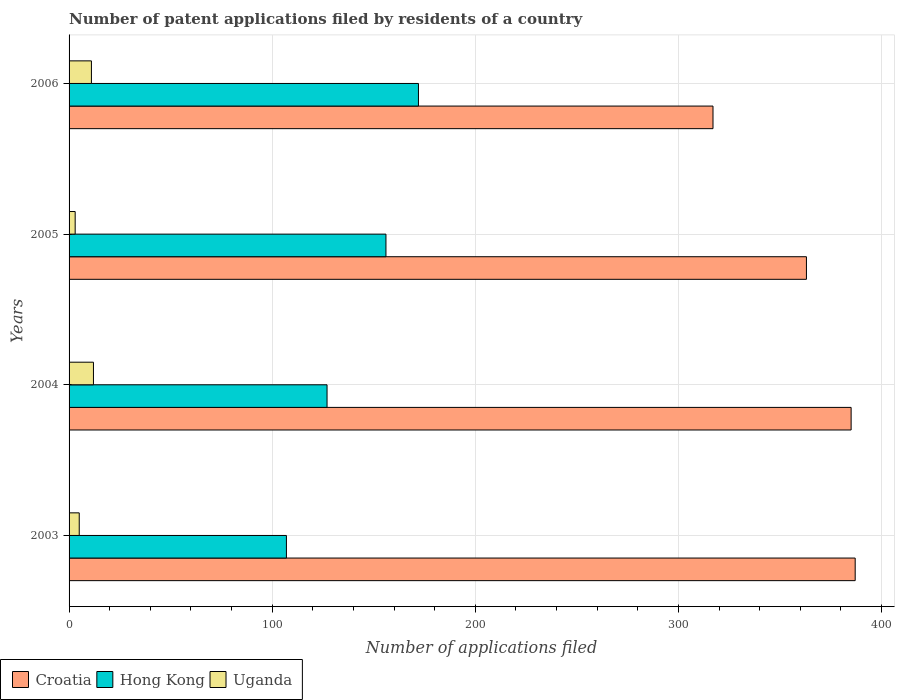How many groups of bars are there?
Provide a succinct answer. 4. How many bars are there on the 3rd tick from the bottom?
Your answer should be very brief. 3. What is the label of the 3rd group of bars from the top?
Provide a succinct answer. 2004. In how many cases, is the number of bars for a given year not equal to the number of legend labels?
Provide a short and direct response. 0. What is the number of applications filed in Hong Kong in 2003?
Your answer should be very brief. 107. Across all years, what is the minimum number of applications filed in Hong Kong?
Your answer should be very brief. 107. In which year was the number of applications filed in Uganda maximum?
Your answer should be very brief. 2004. What is the total number of applications filed in Hong Kong in the graph?
Your answer should be very brief. 562. What is the difference between the number of applications filed in Hong Kong in 2004 and the number of applications filed in Uganda in 2003?
Keep it short and to the point. 122. What is the average number of applications filed in Hong Kong per year?
Offer a very short reply. 140.5. In the year 2006, what is the difference between the number of applications filed in Uganda and number of applications filed in Hong Kong?
Ensure brevity in your answer.  -161. In how many years, is the number of applications filed in Hong Kong greater than 140 ?
Your answer should be compact. 2. What is the ratio of the number of applications filed in Hong Kong in 2005 to that in 2006?
Give a very brief answer. 0.91. Is the number of applications filed in Croatia in 2003 less than that in 2006?
Give a very brief answer. No. What is the difference between the highest and the second highest number of applications filed in Uganda?
Your answer should be very brief. 1. What does the 2nd bar from the top in 2006 represents?
Keep it short and to the point. Hong Kong. What does the 1st bar from the bottom in 2004 represents?
Give a very brief answer. Croatia. Are all the bars in the graph horizontal?
Your answer should be compact. Yes. How many years are there in the graph?
Offer a terse response. 4. What is the difference between two consecutive major ticks on the X-axis?
Give a very brief answer. 100. Are the values on the major ticks of X-axis written in scientific E-notation?
Offer a terse response. No. Where does the legend appear in the graph?
Your answer should be very brief. Bottom left. What is the title of the graph?
Keep it short and to the point. Number of patent applications filed by residents of a country. What is the label or title of the X-axis?
Your response must be concise. Number of applications filed. What is the label or title of the Y-axis?
Offer a terse response. Years. What is the Number of applications filed of Croatia in 2003?
Your answer should be compact. 387. What is the Number of applications filed in Hong Kong in 2003?
Give a very brief answer. 107. What is the Number of applications filed in Uganda in 2003?
Offer a very short reply. 5. What is the Number of applications filed in Croatia in 2004?
Offer a very short reply. 385. What is the Number of applications filed in Hong Kong in 2004?
Make the answer very short. 127. What is the Number of applications filed of Croatia in 2005?
Make the answer very short. 363. What is the Number of applications filed of Hong Kong in 2005?
Keep it short and to the point. 156. What is the Number of applications filed of Uganda in 2005?
Provide a short and direct response. 3. What is the Number of applications filed of Croatia in 2006?
Your response must be concise. 317. What is the Number of applications filed in Hong Kong in 2006?
Give a very brief answer. 172. Across all years, what is the maximum Number of applications filed of Croatia?
Your answer should be very brief. 387. Across all years, what is the maximum Number of applications filed of Hong Kong?
Ensure brevity in your answer.  172. Across all years, what is the minimum Number of applications filed of Croatia?
Provide a short and direct response. 317. Across all years, what is the minimum Number of applications filed of Hong Kong?
Make the answer very short. 107. What is the total Number of applications filed in Croatia in the graph?
Offer a very short reply. 1452. What is the total Number of applications filed in Hong Kong in the graph?
Give a very brief answer. 562. What is the total Number of applications filed in Uganda in the graph?
Your response must be concise. 31. What is the difference between the Number of applications filed in Croatia in 2003 and that in 2004?
Keep it short and to the point. 2. What is the difference between the Number of applications filed in Uganda in 2003 and that in 2004?
Offer a terse response. -7. What is the difference between the Number of applications filed in Hong Kong in 2003 and that in 2005?
Your answer should be compact. -49. What is the difference between the Number of applications filed in Croatia in 2003 and that in 2006?
Your answer should be very brief. 70. What is the difference between the Number of applications filed in Hong Kong in 2003 and that in 2006?
Offer a terse response. -65. What is the difference between the Number of applications filed of Uganda in 2003 and that in 2006?
Your answer should be compact. -6. What is the difference between the Number of applications filed in Croatia in 2004 and that in 2005?
Give a very brief answer. 22. What is the difference between the Number of applications filed of Uganda in 2004 and that in 2005?
Provide a short and direct response. 9. What is the difference between the Number of applications filed of Croatia in 2004 and that in 2006?
Ensure brevity in your answer.  68. What is the difference between the Number of applications filed in Hong Kong in 2004 and that in 2006?
Make the answer very short. -45. What is the difference between the Number of applications filed of Uganda in 2004 and that in 2006?
Give a very brief answer. 1. What is the difference between the Number of applications filed of Croatia in 2005 and that in 2006?
Your answer should be very brief. 46. What is the difference between the Number of applications filed in Croatia in 2003 and the Number of applications filed in Hong Kong in 2004?
Offer a terse response. 260. What is the difference between the Number of applications filed in Croatia in 2003 and the Number of applications filed in Uganda in 2004?
Make the answer very short. 375. What is the difference between the Number of applications filed of Hong Kong in 2003 and the Number of applications filed of Uganda in 2004?
Ensure brevity in your answer.  95. What is the difference between the Number of applications filed of Croatia in 2003 and the Number of applications filed of Hong Kong in 2005?
Make the answer very short. 231. What is the difference between the Number of applications filed of Croatia in 2003 and the Number of applications filed of Uganda in 2005?
Your response must be concise. 384. What is the difference between the Number of applications filed of Hong Kong in 2003 and the Number of applications filed of Uganda in 2005?
Offer a terse response. 104. What is the difference between the Number of applications filed of Croatia in 2003 and the Number of applications filed of Hong Kong in 2006?
Make the answer very short. 215. What is the difference between the Number of applications filed in Croatia in 2003 and the Number of applications filed in Uganda in 2006?
Your answer should be very brief. 376. What is the difference between the Number of applications filed in Hong Kong in 2003 and the Number of applications filed in Uganda in 2006?
Your answer should be very brief. 96. What is the difference between the Number of applications filed of Croatia in 2004 and the Number of applications filed of Hong Kong in 2005?
Ensure brevity in your answer.  229. What is the difference between the Number of applications filed of Croatia in 2004 and the Number of applications filed of Uganda in 2005?
Your answer should be very brief. 382. What is the difference between the Number of applications filed in Hong Kong in 2004 and the Number of applications filed in Uganda in 2005?
Provide a succinct answer. 124. What is the difference between the Number of applications filed of Croatia in 2004 and the Number of applications filed of Hong Kong in 2006?
Keep it short and to the point. 213. What is the difference between the Number of applications filed in Croatia in 2004 and the Number of applications filed in Uganda in 2006?
Make the answer very short. 374. What is the difference between the Number of applications filed in Hong Kong in 2004 and the Number of applications filed in Uganda in 2006?
Provide a succinct answer. 116. What is the difference between the Number of applications filed of Croatia in 2005 and the Number of applications filed of Hong Kong in 2006?
Keep it short and to the point. 191. What is the difference between the Number of applications filed in Croatia in 2005 and the Number of applications filed in Uganda in 2006?
Offer a very short reply. 352. What is the difference between the Number of applications filed in Hong Kong in 2005 and the Number of applications filed in Uganda in 2006?
Your response must be concise. 145. What is the average Number of applications filed in Croatia per year?
Your answer should be compact. 363. What is the average Number of applications filed in Hong Kong per year?
Provide a succinct answer. 140.5. What is the average Number of applications filed in Uganda per year?
Provide a short and direct response. 7.75. In the year 2003, what is the difference between the Number of applications filed in Croatia and Number of applications filed in Hong Kong?
Provide a succinct answer. 280. In the year 2003, what is the difference between the Number of applications filed of Croatia and Number of applications filed of Uganda?
Provide a short and direct response. 382. In the year 2003, what is the difference between the Number of applications filed of Hong Kong and Number of applications filed of Uganda?
Provide a succinct answer. 102. In the year 2004, what is the difference between the Number of applications filed in Croatia and Number of applications filed in Hong Kong?
Make the answer very short. 258. In the year 2004, what is the difference between the Number of applications filed of Croatia and Number of applications filed of Uganda?
Your answer should be compact. 373. In the year 2004, what is the difference between the Number of applications filed in Hong Kong and Number of applications filed in Uganda?
Make the answer very short. 115. In the year 2005, what is the difference between the Number of applications filed in Croatia and Number of applications filed in Hong Kong?
Offer a terse response. 207. In the year 2005, what is the difference between the Number of applications filed of Croatia and Number of applications filed of Uganda?
Offer a terse response. 360. In the year 2005, what is the difference between the Number of applications filed of Hong Kong and Number of applications filed of Uganda?
Give a very brief answer. 153. In the year 2006, what is the difference between the Number of applications filed of Croatia and Number of applications filed of Hong Kong?
Provide a short and direct response. 145. In the year 2006, what is the difference between the Number of applications filed in Croatia and Number of applications filed in Uganda?
Provide a short and direct response. 306. In the year 2006, what is the difference between the Number of applications filed in Hong Kong and Number of applications filed in Uganda?
Your answer should be compact. 161. What is the ratio of the Number of applications filed in Croatia in 2003 to that in 2004?
Provide a short and direct response. 1.01. What is the ratio of the Number of applications filed in Hong Kong in 2003 to that in 2004?
Offer a terse response. 0.84. What is the ratio of the Number of applications filed in Uganda in 2003 to that in 2004?
Provide a succinct answer. 0.42. What is the ratio of the Number of applications filed in Croatia in 2003 to that in 2005?
Make the answer very short. 1.07. What is the ratio of the Number of applications filed in Hong Kong in 2003 to that in 2005?
Provide a succinct answer. 0.69. What is the ratio of the Number of applications filed of Croatia in 2003 to that in 2006?
Your answer should be compact. 1.22. What is the ratio of the Number of applications filed of Hong Kong in 2003 to that in 2006?
Provide a short and direct response. 0.62. What is the ratio of the Number of applications filed in Uganda in 2003 to that in 2006?
Provide a succinct answer. 0.45. What is the ratio of the Number of applications filed in Croatia in 2004 to that in 2005?
Ensure brevity in your answer.  1.06. What is the ratio of the Number of applications filed of Hong Kong in 2004 to that in 2005?
Your response must be concise. 0.81. What is the ratio of the Number of applications filed in Croatia in 2004 to that in 2006?
Offer a very short reply. 1.21. What is the ratio of the Number of applications filed of Hong Kong in 2004 to that in 2006?
Your answer should be very brief. 0.74. What is the ratio of the Number of applications filed of Croatia in 2005 to that in 2006?
Offer a terse response. 1.15. What is the ratio of the Number of applications filed of Hong Kong in 2005 to that in 2006?
Give a very brief answer. 0.91. What is the ratio of the Number of applications filed in Uganda in 2005 to that in 2006?
Give a very brief answer. 0.27. What is the difference between the highest and the second highest Number of applications filed of Croatia?
Your answer should be compact. 2. What is the difference between the highest and the lowest Number of applications filed of Croatia?
Your answer should be very brief. 70. What is the difference between the highest and the lowest Number of applications filed of Hong Kong?
Give a very brief answer. 65. What is the difference between the highest and the lowest Number of applications filed of Uganda?
Ensure brevity in your answer.  9. 